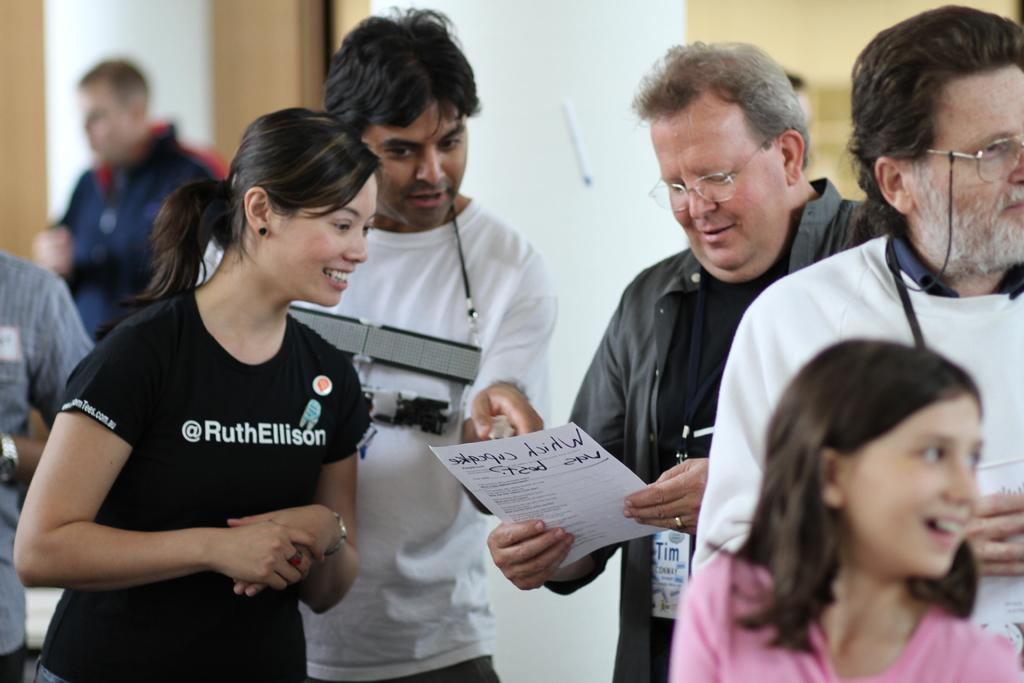How many people are in the image? There are persons in the image. Can you describe the gender of the people in the image? There are both men and women in the image. What is one of the persons doing with their hands? One of the persons is holding a paper. What type of flesh can be seen on the person holding the paper in the image? There is no flesh visible on the person holding the paper in the image. 